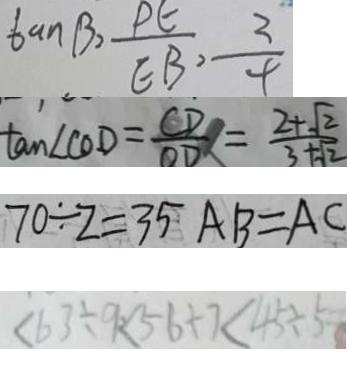Convert formula to latex. <formula><loc_0><loc_0><loc_500><loc_500>\tan \beta = \frac { P E } { E B } , \frac { 3 } { 4 } 
 \tan \angle C O D = \frac { C D } { O D } = \frac { 2 + \sqrt { 2 } } { 3 + \sqrt { 2 } } 
 7 0 \div 2 = 3 5 A B = A C 
 < 6 3 \div 9 < 5 6 + 7 < 4 5 \div 5</formula> 